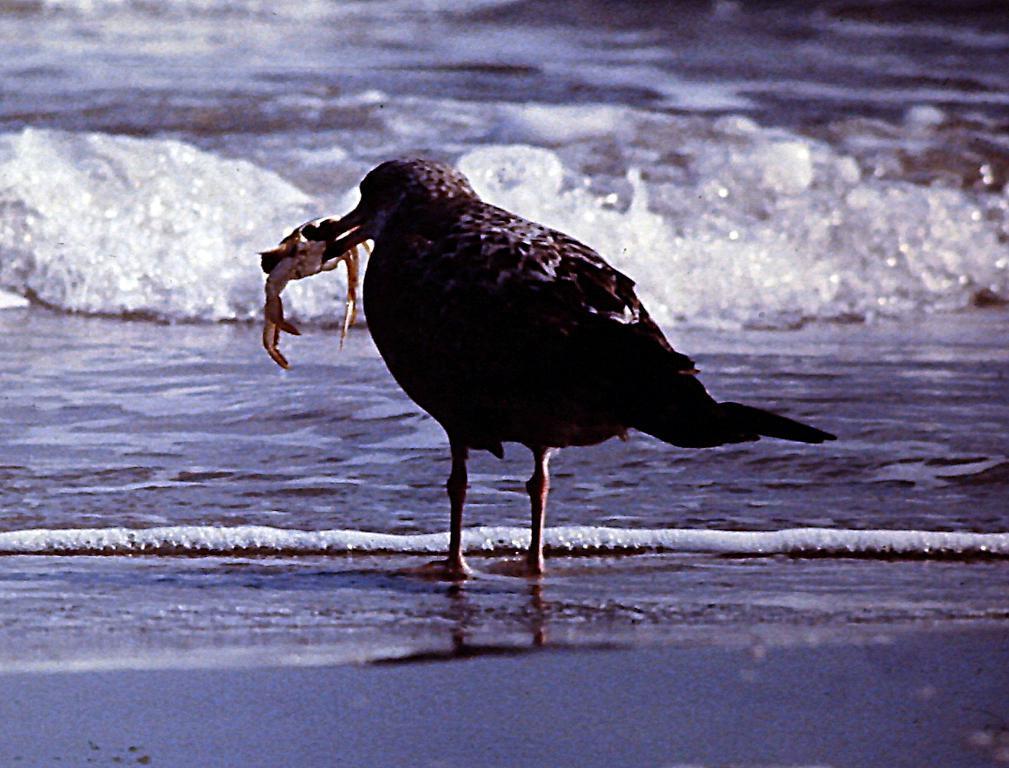Describe this image in one or two sentences. In the center of the picture there is a bird holding a crab. In the background there is a water body. At the bottom it is looking like sand. 